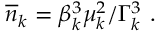Convert formula to latex. <formula><loc_0><loc_0><loc_500><loc_500>\overline { n } _ { k } = \beta _ { k } ^ { 3 } \mu _ { k } ^ { 2 } / \Gamma _ { k } ^ { 3 } \ .</formula> 